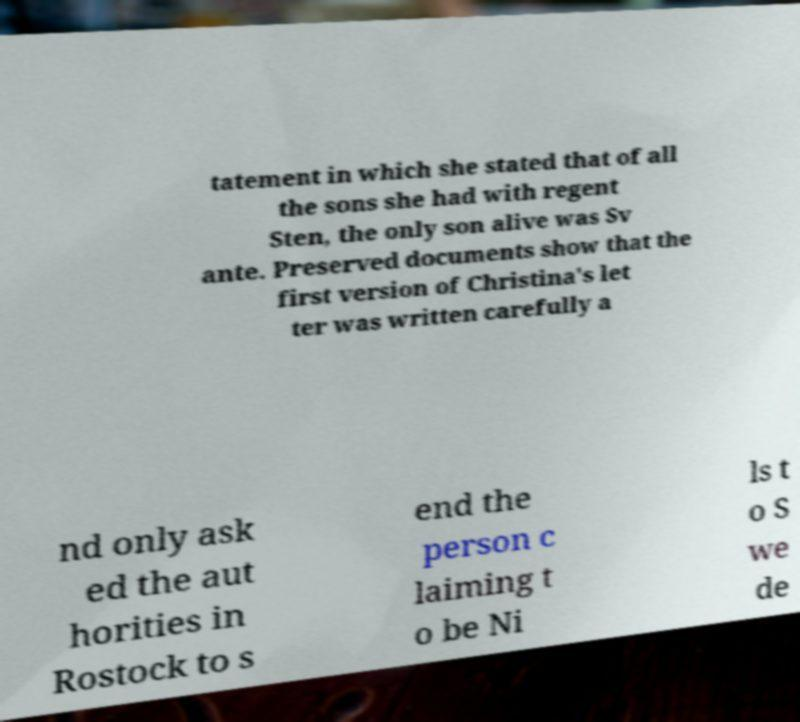Could you assist in decoding the text presented in this image and type it out clearly? tatement in which she stated that of all the sons she had with regent Sten, the only son alive was Sv ante. Preserved documents show that the first version of Christina's let ter was written carefully a nd only ask ed the aut horities in Rostock to s end the person c laiming t o be Ni ls t o S we de 